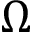Convert formula to latex. <formula><loc_0><loc_0><loc_500><loc_500>\Omega</formula> 